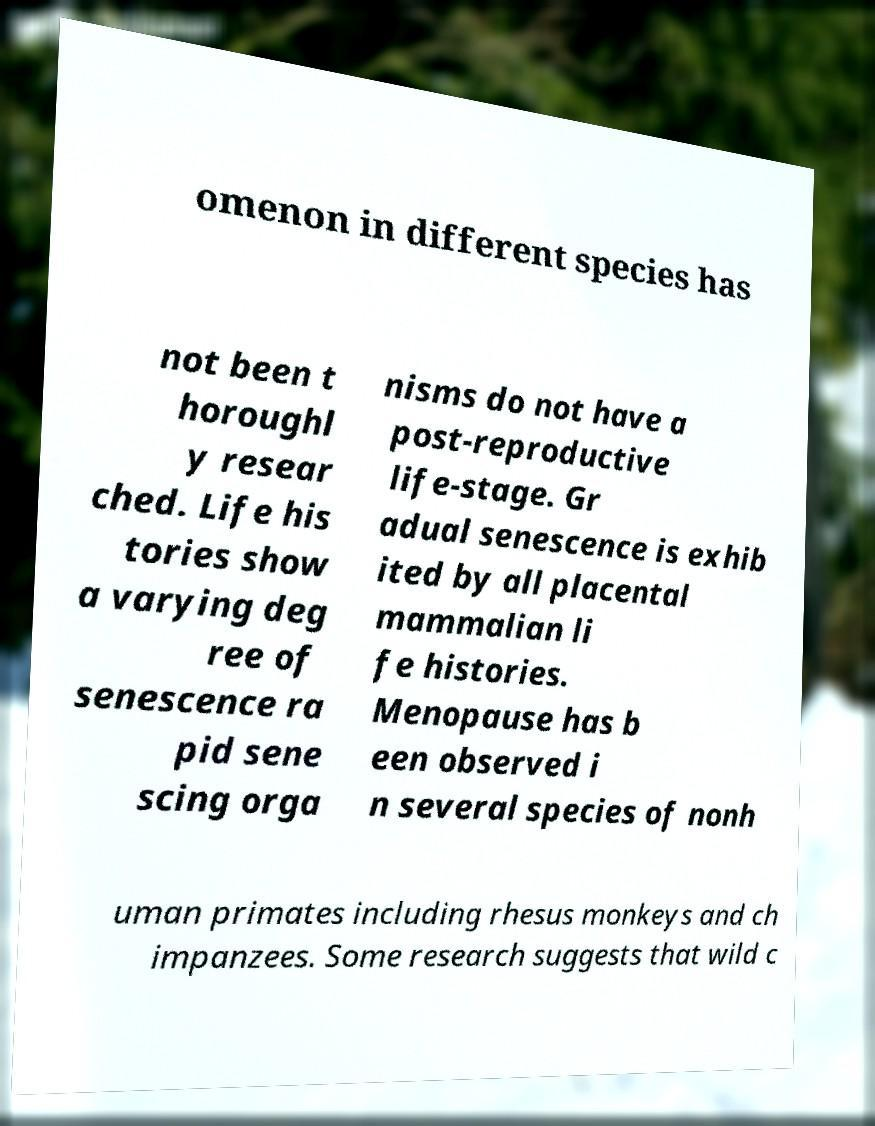Can you accurately transcribe the text from the provided image for me? omenon in different species has not been t horoughl y resear ched. Life his tories show a varying deg ree of senescence ra pid sene scing orga nisms do not have a post-reproductive life-stage. Gr adual senescence is exhib ited by all placental mammalian li fe histories. Menopause has b een observed i n several species of nonh uman primates including rhesus monkeys and ch impanzees. Some research suggests that wild c 